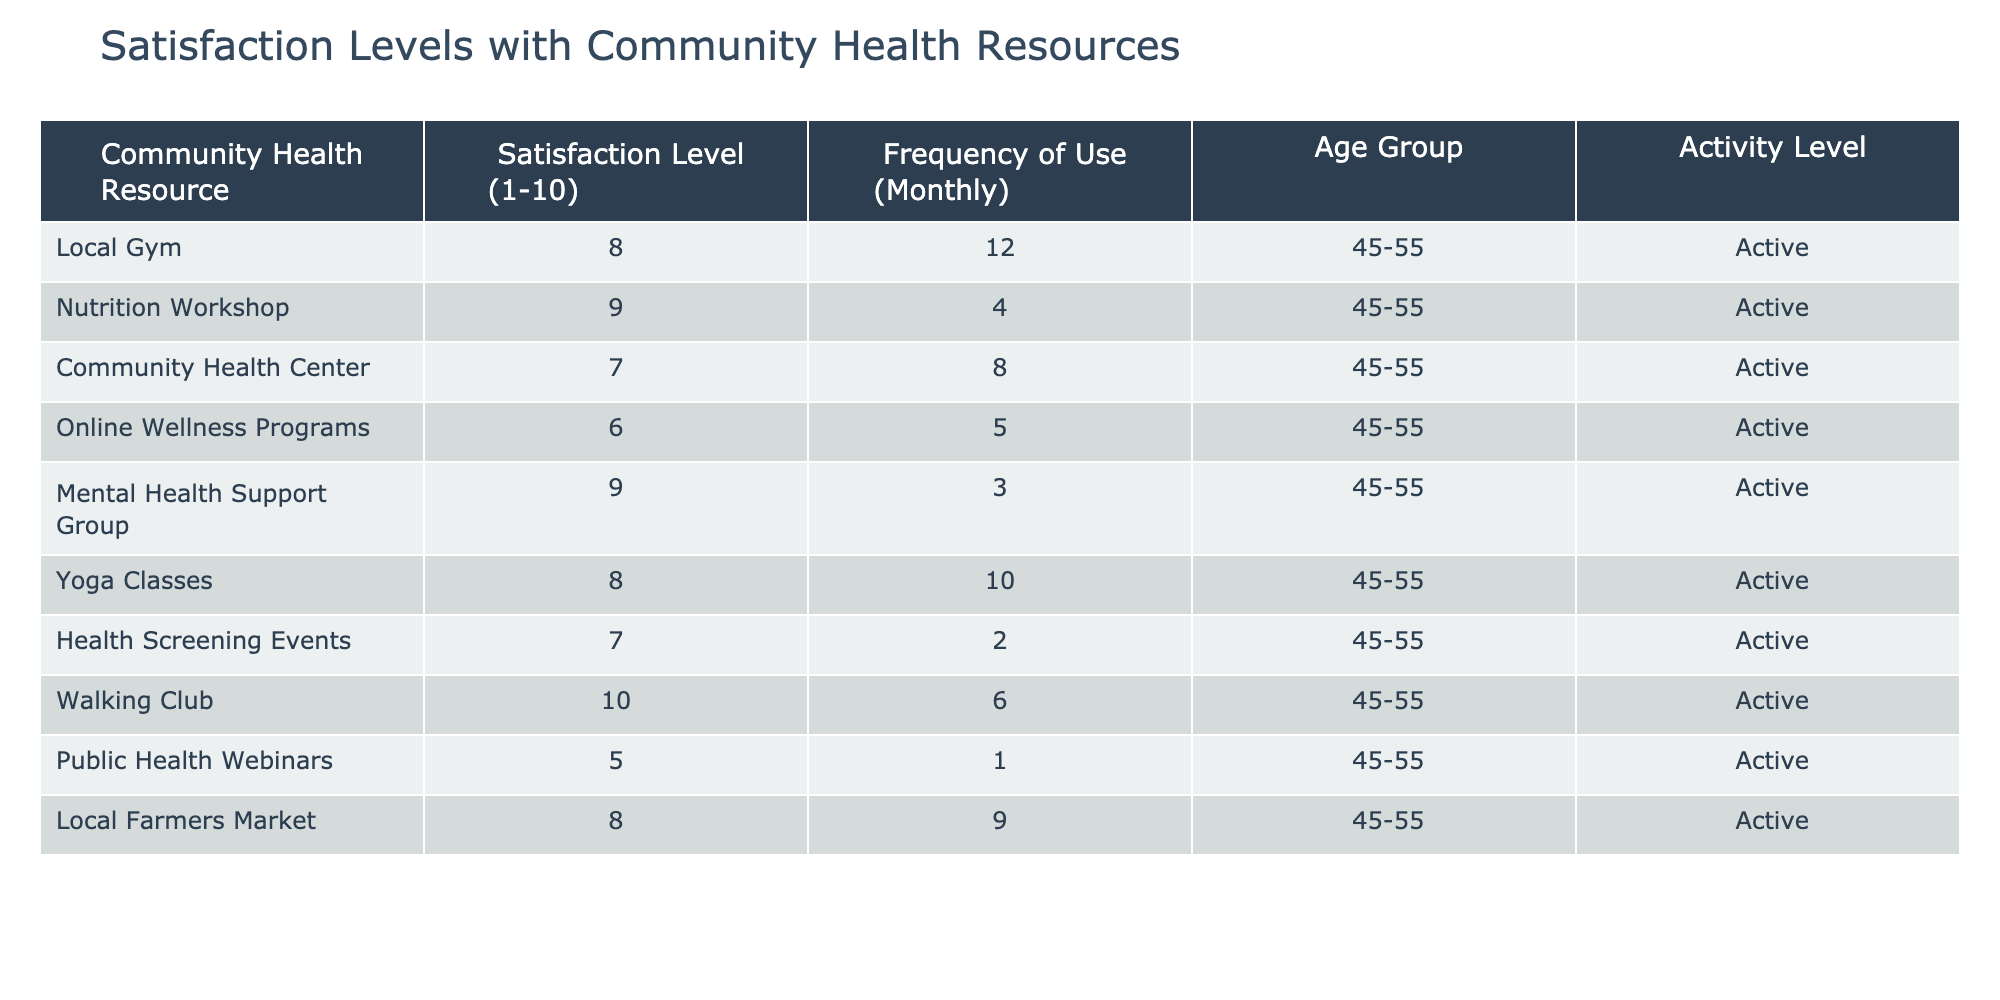What is the satisfaction level for the Nutrition Workshop? The Nutrition Workshop has a satisfaction level of 9 as indicated in the second row of the table.
Answer: 9 How many community health resources have a satisfaction level of 8 or higher? The resources with a satisfaction level of 8 or higher are the Local Gym, Nutrition Workshop, Mental Health Support Group, Yoga Classes, and Walking Club. That's a total of 5 resources.
Answer: 5 Which resource has the highest frequency of use? The resource with the highest frequency of use is the Local Gym, with a frequency of use of 12 times per month, as noted in the first row.
Answer: Local Gym Is the satisfaction level for Online Wellness Programs greater than that of Public Health Webinars? Yes, the satisfaction level for Online Wellness Programs is 6 and for Public Health Webinars it is 5, so Online Wellness Programs is indeed greater.
Answer: Yes What is the average satisfaction level of all resources listed? The satisfaction levels are 8, 9, 7, 6, 9, 8, 7, 10, 5, and 8. Summing these gives us 77, and since there are 10 resources, the average is 77 divided by 10, which is 7.7.
Answer: 7.7 Which community health resource had the lowest frequency of use among active women? The resource with the lowest frequency of use is the Public Health Webinars, which had a frequency of use of only 1 time per month.
Answer: Public Health Webinars How does the satisfaction level of the Walking Club compare to that of the Community Health Center? The Walking Club has a satisfaction level of 10 while the Community Health Center has a satisfaction level of 7. Therefore, the Walking Club has a higher satisfaction level than the Community Health Center.
Answer: Walking Club has a higher satisfaction level How many resources have a satisfaction level lower than 7, and what are their names? The resources with a satisfaction level lower than 7 are the Community Health Center (7), Online Wellness Programs (6), Health Screening Events (7), and Public Health Webinars (5). So, only Public Health Webinars (5) is below 7, indicating it's the only one.
Answer: Public Health Webinars 